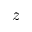Convert formula to latex. <formula><loc_0><loc_0><loc_500><loc_500>z</formula> 